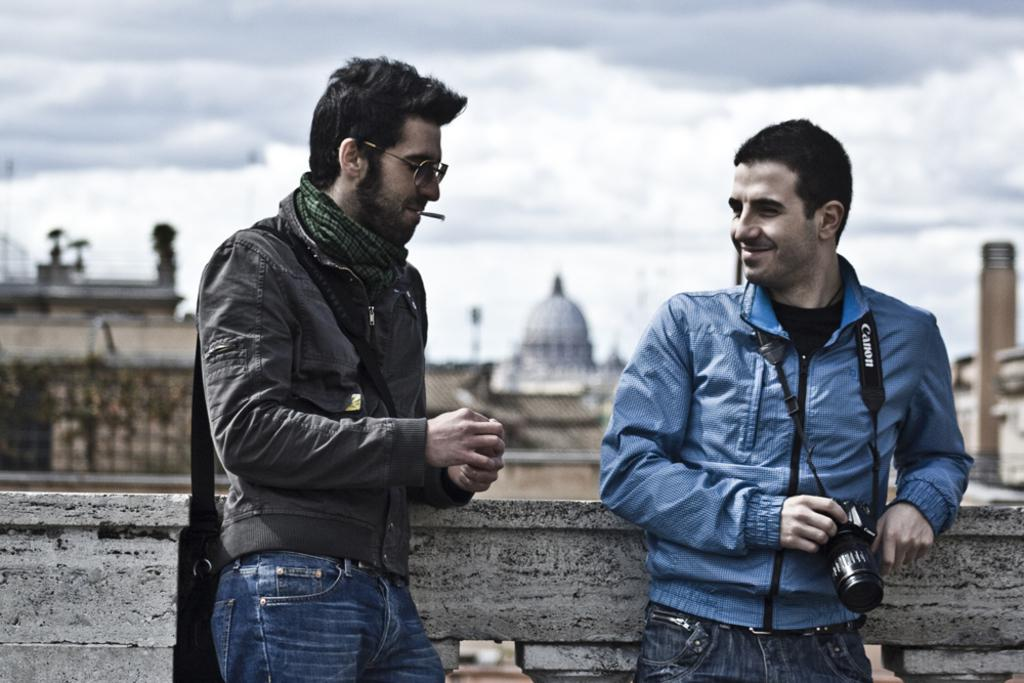How many men are in the image? There are two men in the image. Can you describe the appearance of the man on the left side? The man on the left side is wearing spectacles. What is the man on the right side holding? The man on the right side is holding a camera. What can be seen in the background of the image? There are buildings and clouds visible in the background of the image. Is there a goose walking around at the party in the image? There is no party or goose present in the image. How does the man on the right side stop the camera from taking pictures? The man on the right side is not trying to stop the camera from taking pictures; he is holding it, but there is no indication of him stopping it. 